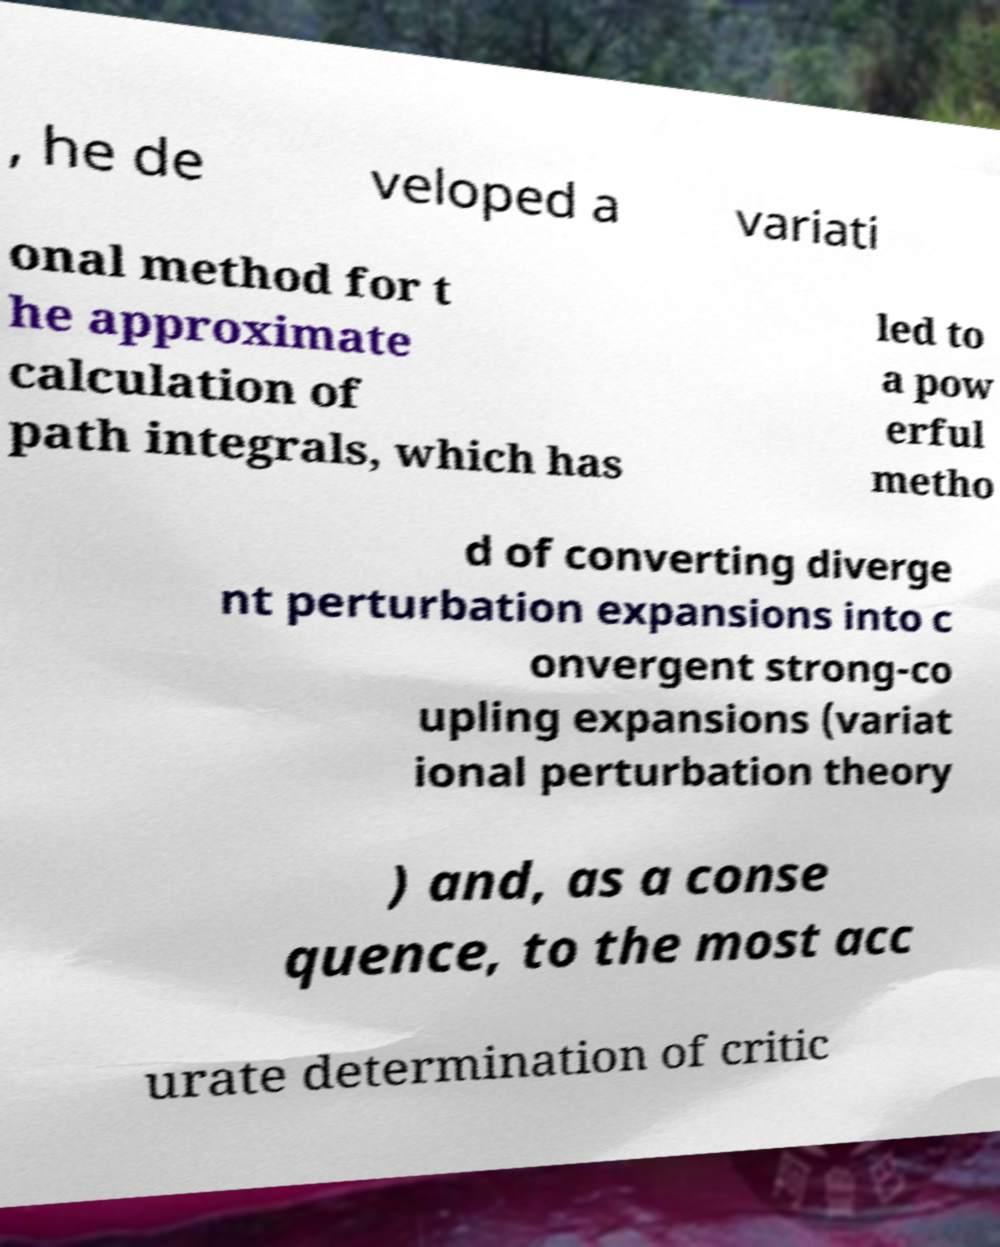Can you read and provide the text displayed in the image?This photo seems to have some interesting text. Can you extract and type it out for me? , he de veloped a variati onal method for t he approximate calculation of path integrals, which has led to a pow erful metho d of converting diverge nt perturbation expansions into c onvergent strong-co upling expansions (variat ional perturbation theory ) and, as a conse quence, to the most acc urate determination of critic 